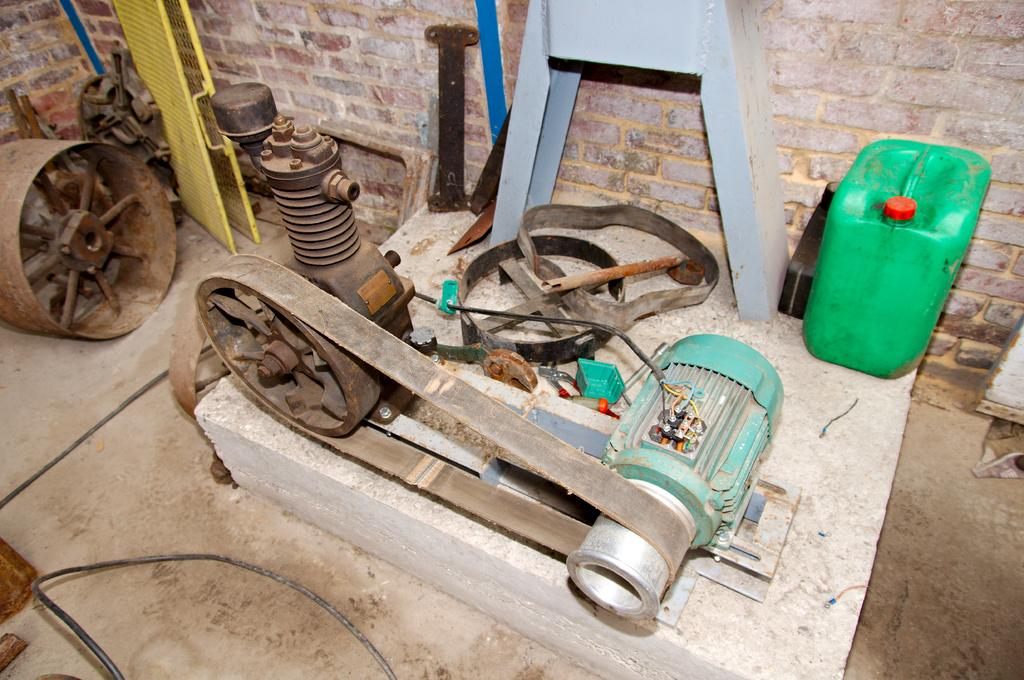What is the main object in the image? There is a motor in the image. What is connected to the motor? The motor has a belt attached to it. What else can be seen in the image besides the motor and belt? There are other objects beside the motor. What is the aftermath of the motor's operation in the image? There is no indication of any aftermath in the image, as it only shows the motor and the belt attached to it. 